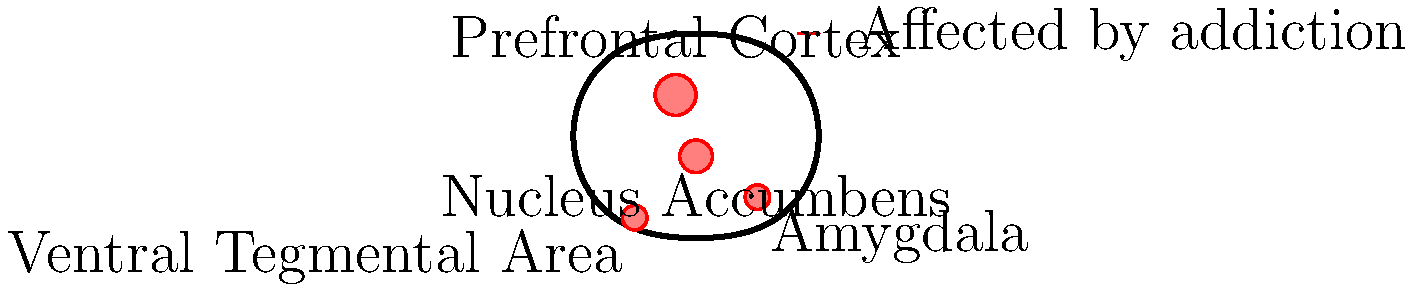Based on the labeled diagram of the brain, which region is primarily responsible for decision-making and impulse control, and how is it affected in drug addiction? To answer this question, let's analyze the brain regions shown in the diagram and their roles in drug addiction:

1. The diagram highlights four main regions affected by drug addiction: the Prefrontal Cortex, Nucleus Accumbens, Amygdala, and Ventral Tegmental Area.

2. Among these regions, the Prefrontal Cortex is primarily responsible for executive functions, including decision-making and impulse control.

3. In drug addiction, the Prefrontal Cortex is significantly impaired:
   a) Chronic drug use leads to structural and functional changes in this region.
   b) These changes result in decreased gray matter volume and altered neural activity.
   c) As a consequence, addicted individuals often exhibit poor decision-making skills and reduced impulse control.

4. The impairment of the Prefrontal Cortex contributes to the cycle of addiction by:
   a) Weakening the ability to resist drug cravings
   b) Impairing judgment about the consequences of drug use
   c) Reducing the capacity to make long-term, goal-oriented decisions

5. This dysfunction in the Prefrontal Cortex interacts with other affected regions:
   a) The Nucleus Accumbens (reward center) becomes hypersensitive to drug cues
   b) The Amygdala (emotion processing) shows heightened reactivity to stress and drug cues
   c) The Ventral Tegmental Area (dopamine production) has altered signaling patterns

In summary, the Prefrontal Cortex is the key region responsible for decision-making and impulse control, and its impairment in drug addiction significantly contributes to the maintenance of addictive behaviors.
Answer: Prefrontal Cortex; impaired function leads to poor decision-making and reduced impulse control 